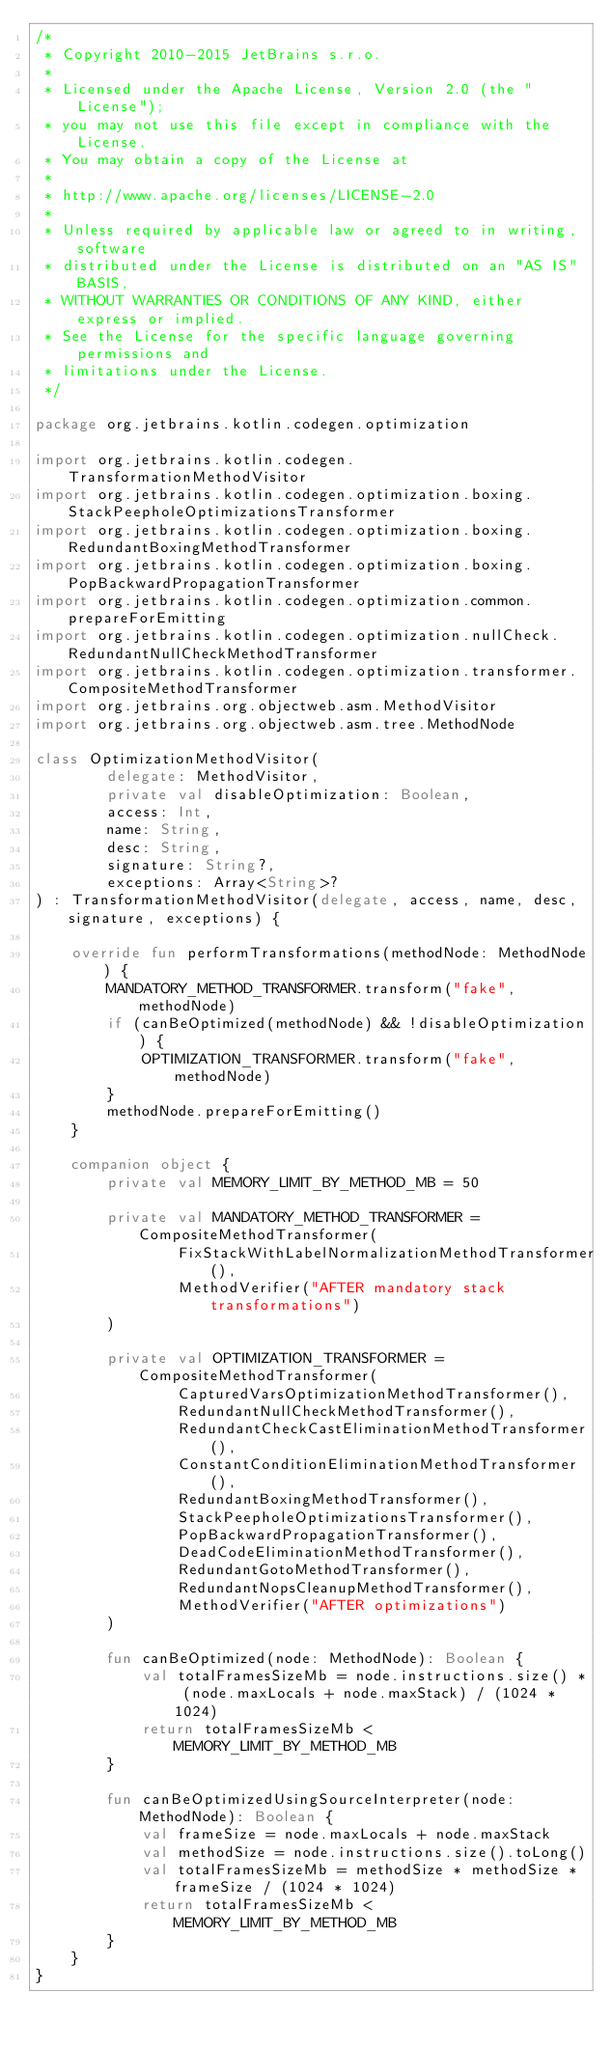Convert code to text. <code><loc_0><loc_0><loc_500><loc_500><_Kotlin_>/*
 * Copyright 2010-2015 JetBrains s.r.o.
 *
 * Licensed under the Apache License, Version 2.0 (the "License");
 * you may not use this file except in compliance with the License.
 * You may obtain a copy of the License at
 *
 * http://www.apache.org/licenses/LICENSE-2.0
 *
 * Unless required by applicable law or agreed to in writing, software
 * distributed under the License is distributed on an "AS IS" BASIS,
 * WITHOUT WARRANTIES OR CONDITIONS OF ANY KIND, either express or implied.
 * See the License for the specific language governing permissions and
 * limitations under the License.
 */

package org.jetbrains.kotlin.codegen.optimization

import org.jetbrains.kotlin.codegen.TransformationMethodVisitor
import org.jetbrains.kotlin.codegen.optimization.boxing.StackPeepholeOptimizationsTransformer
import org.jetbrains.kotlin.codegen.optimization.boxing.RedundantBoxingMethodTransformer
import org.jetbrains.kotlin.codegen.optimization.boxing.PopBackwardPropagationTransformer
import org.jetbrains.kotlin.codegen.optimization.common.prepareForEmitting
import org.jetbrains.kotlin.codegen.optimization.nullCheck.RedundantNullCheckMethodTransformer
import org.jetbrains.kotlin.codegen.optimization.transformer.CompositeMethodTransformer
import org.jetbrains.org.objectweb.asm.MethodVisitor
import org.jetbrains.org.objectweb.asm.tree.MethodNode

class OptimizationMethodVisitor(
        delegate: MethodVisitor,
        private val disableOptimization: Boolean,
        access: Int,
        name: String,
        desc: String,
        signature: String?,
        exceptions: Array<String>?
) : TransformationMethodVisitor(delegate, access, name, desc, signature, exceptions) {

    override fun performTransformations(methodNode: MethodNode) {
        MANDATORY_METHOD_TRANSFORMER.transform("fake", methodNode)
        if (canBeOptimized(methodNode) && !disableOptimization) {
            OPTIMIZATION_TRANSFORMER.transform("fake", methodNode)
        }
        methodNode.prepareForEmitting()
    }

    companion object {
        private val MEMORY_LIMIT_BY_METHOD_MB = 50

        private val MANDATORY_METHOD_TRANSFORMER = CompositeMethodTransformer(
                FixStackWithLabelNormalizationMethodTransformer(),
                MethodVerifier("AFTER mandatory stack transformations")
        )

        private val OPTIMIZATION_TRANSFORMER = CompositeMethodTransformer(
                CapturedVarsOptimizationMethodTransformer(),
                RedundantNullCheckMethodTransformer(),
                RedundantCheckCastEliminationMethodTransformer(),
                ConstantConditionEliminationMethodTransformer(),
                RedundantBoxingMethodTransformer(),
                StackPeepholeOptimizationsTransformer(),
                PopBackwardPropagationTransformer(),
                DeadCodeEliminationMethodTransformer(),
                RedundantGotoMethodTransformer(),
                RedundantNopsCleanupMethodTransformer(),
                MethodVerifier("AFTER optimizations")
        )

        fun canBeOptimized(node: MethodNode): Boolean {
            val totalFramesSizeMb = node.instructions.size() * (node.maxLocals + node.maxStack) / (1024 * 1024)
            return totalFramesSizeMb < MEMORY_LIMIT_BY_METHOD_MB
        }

        fun canBeOptimizedUsingSourceInterpreter(node: MethodNode): Boolean {
            val frameSize = node.maxLocals + node.maxStack
            val methodSize = node.instructions.size().toLong()
            val totalFramesSizeMb = methodSize * methodSize * frameSize / (1024 * 1024)
            return totalFramesSizeMb < MEMORY_LIMIT_BY_METHOD_MB
        }
    }
}
</code> 